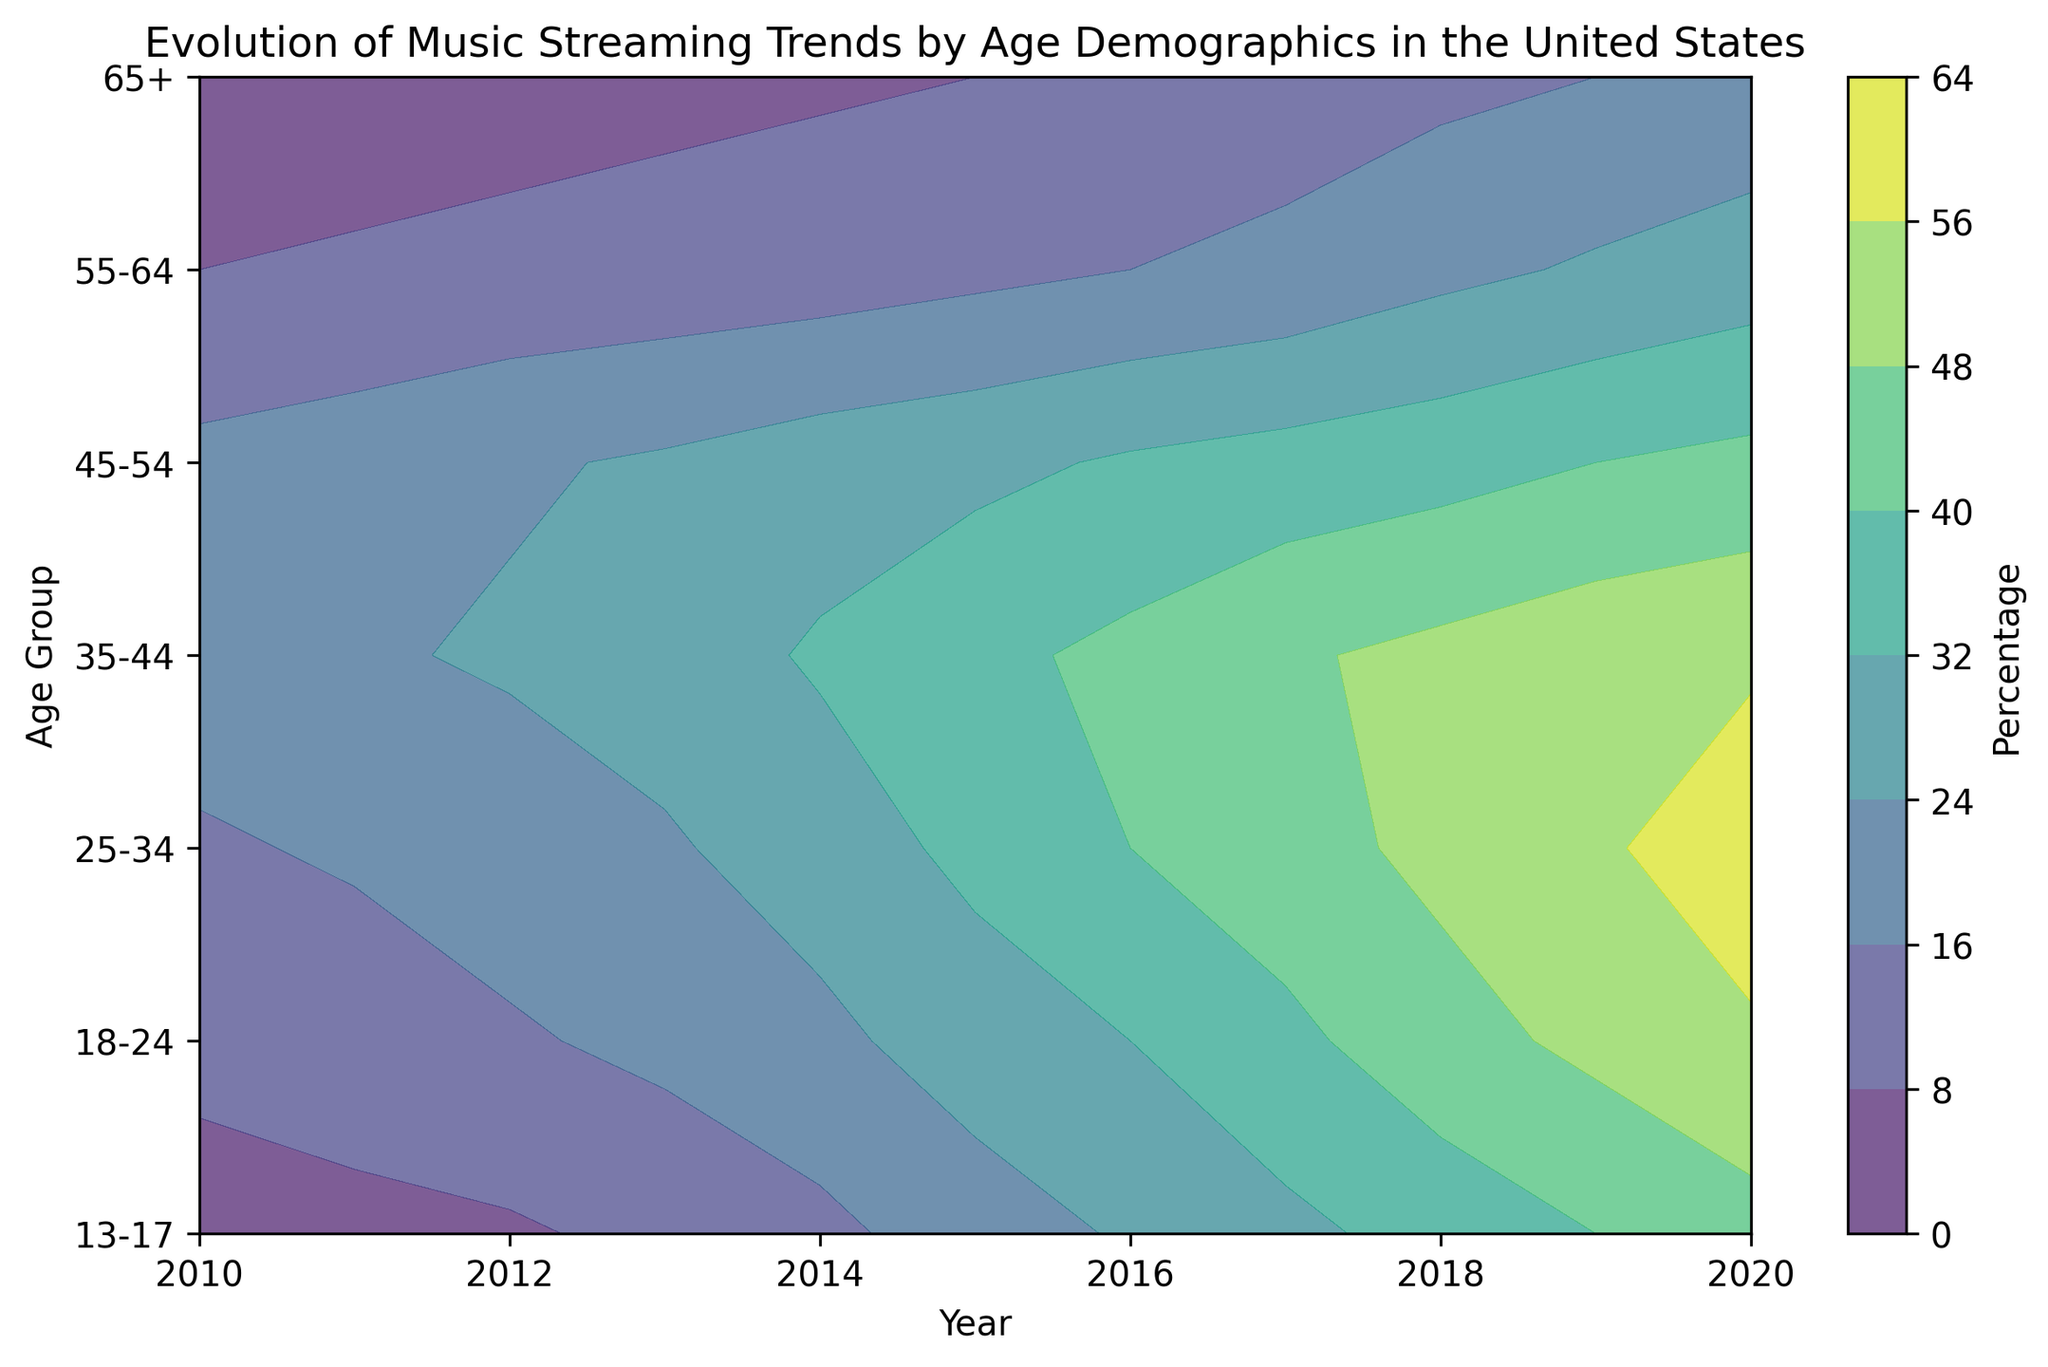What is the overall trend in music streaming percentages for the 13-17 age group from 2010 to 2020? In the figure, locate the contour for the 13-17 age group and observe the percentage values at both ends of the timeline. The percentage starts at 5% in 2010 and rises to 45% by 2020, indicating a general upward trend.
Answer: Upward trend Which age group shows the highest increase in streaming percentage from 2010 to 2020? Compare the starting and ending values for each age group in the figure. The 25-34 age group increases from 15% in 2010 to 60% in 2020, which is the highest absolute increase of 45 percentage points.
Answer: 25-34 Between the years 2015 and 2020, which age group shows the smallest increase in streaming percentage? Compare the differences in percentage for each age group between 2015 and 2020. The 45-54 age group rises from 30% to 42%, giving an increase of 12 percentage points, which is the smallest.
Answer: 45-54 In which year did the 18-24 age group reach a streaming percentage of 28%? Look through the contour values for the 18-24 age group and find the year where the percentage is 28%. It occurs in 2015.
Answer: 2015 How does the streaming percentage for the 35-44 age group in 2020 compare to the 18-24 age group in 2015? Locate the 2020 value for the 35-44 age group, which is 55%, and the 2015 value for the 18-24 age group, which is 28%. The 2020 value for the 35-44 age group is higher.
Answer: Higher in 2020 for 35-44 Which age group had a steady increase without any dips from 2010 to 2020? Observe the contour lines for each age group; the 25-34 and 35-44 age groups show a consistent rise with no dips over the years.
Answer: 25-34, 35-44 What is the average streaming percentage for the 55-64 age group over the decade from 2010 to 2020? Sum up the yearly percentages for the 55-64 age group: 8, 9, 10, 11, 12, 14, 16, 18, 22, 25, 28. Then divide by the number of years (11) to get the average: (8+9+10+11+12+14+16+18+22+25+28)/11 = 17
Answer: 17 